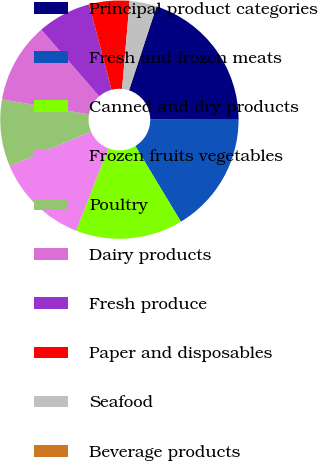Convert chart to OTSL. <chart><loc_0><loc_0><loc_500><loc_500><pie_chart><fcel>Principal product categories<fcel>Fresh and frozen meats<fcel>Canned and dry products<fcel>Frozen fruits vegetables<fcel>Poultry<fcel>Dairy products<fcel>Fresh produce<fcel>Paper and disposables<fcel>Seafood<fcel>Beverage products<nl><fcel>19.97%<fcel>16.35%<fcel>14.53%<fcel>12.72%<fcel>9.09%<fcel>10.91%<fcel>7.28%<fcel>5.47%<fcel>3.65%<fcel>0.03%<nl></chart> 